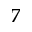<formula> <loc_0><loc_0><loc_500><loc_500>7</formula> 